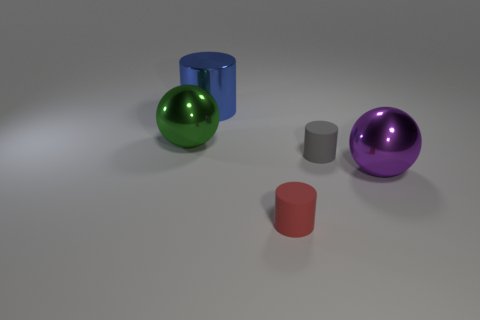Is there a large shiny object of the same color as the metal cylinder?
Ensure brevity in your answer.  No. Is the number of metal objects in front of the green thing the same as the number of large things?
Offer a very short reply. No. How many small cylinders are there?
Make the answer very short. 2. What shape is the shiny object that is both behind the gray cylinder and in front of the big blue metallic cylinder?
Provide a succinct answer. Sphere. There is a metallic sphere on the right side of the blue object; is it the same color as the metal ball to the left of the big blue metal cylinder?
Your answer should be compact. No. Is there a large cylinder made of the same material as the large green thing?
Your answer should be very brief. Yes. Is the number of gray objects that are to the left of the green metal object the same as the number of large blue metal cylinders that are on the right side of the purple sphere?
Offer a terse response. Yes. There is a matte thing that is on the left side of the gray rubber object; what is its size?
Provide a short and direct response. Small. The small object that is behind the metal object that is to the right of the large blue thing is made of what material?
Make the answer very short. Rubber. There is a sphere to the right of the gray matte thing on the right side of the blue thing; how many large objects are to the right of it?
Ensure brevity in your answer.  0. 